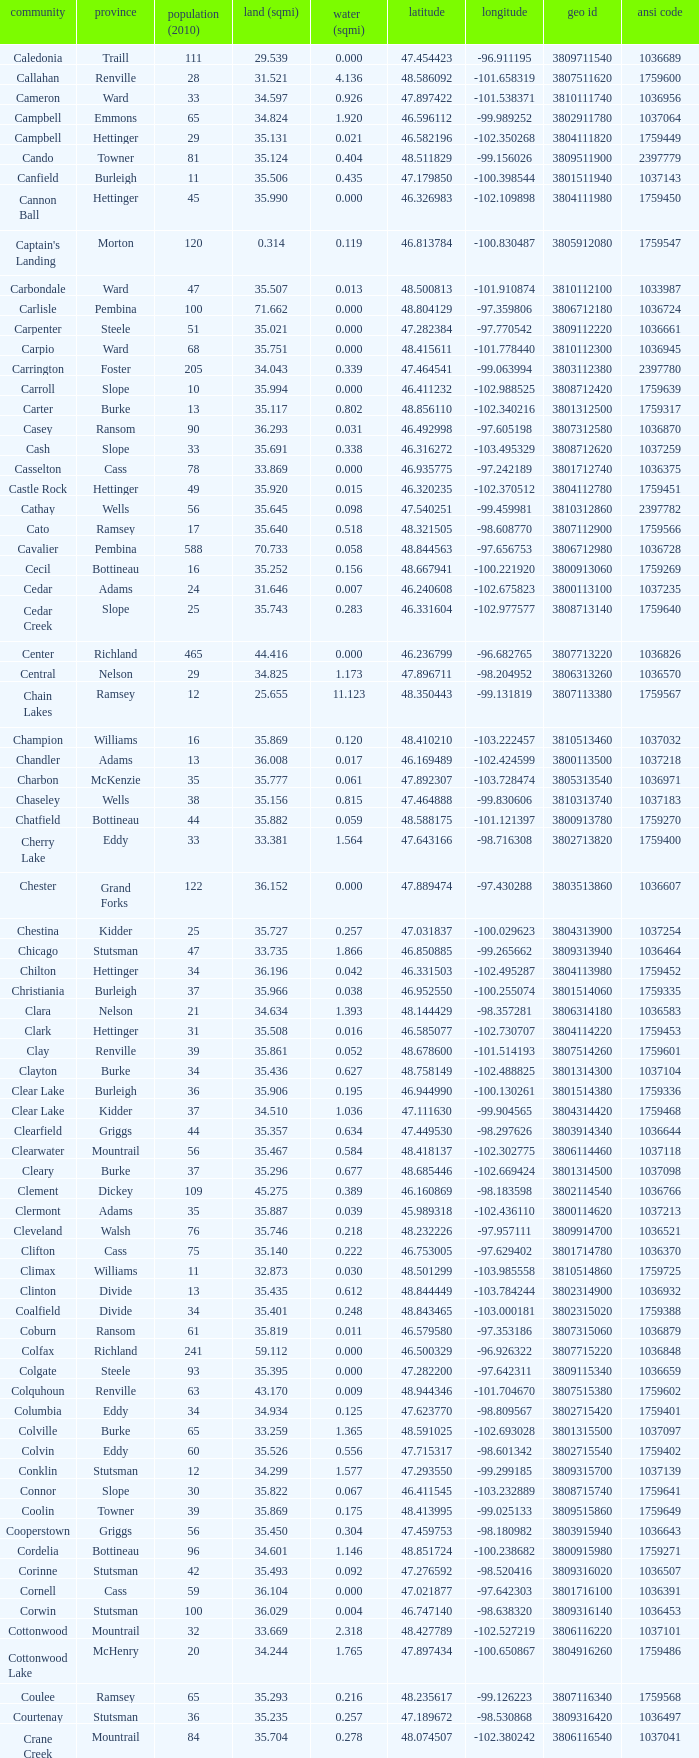What was the county with a latitude of 46.770977? Kidder. 